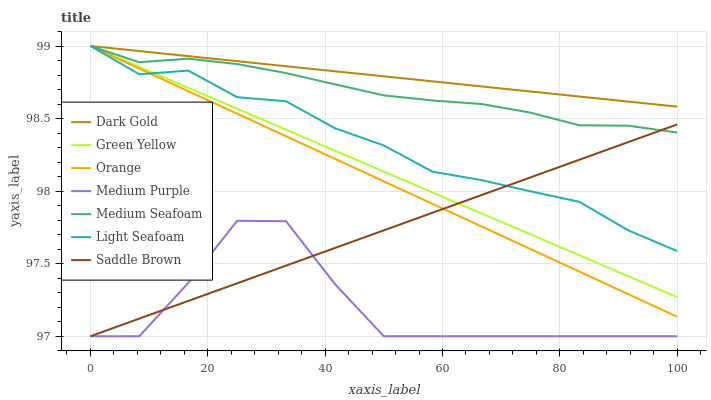Does Medium Purple have the minimum area under the curve?
Answer yes or no. Yes. Does Dark Gold have the maximum area under the curve?
Answer yes or no. Yes. Does Saddle Brown have the minimum area under the curve?
Answer yes or no. No. Does Saddle Brown have the maximum area under the curve?
Answer yes or no. No. Is Dark Gold the smoothest?
Answer yes or no. Yes. Is Medium Purple the roughest?
Answer yes or no. Yes. Is Saddle Brown the smoothest?
Answer yes or no. No. Is Saddle Brown the roughest?
Answer yes or no. No. Does Saddle Brown have the lowest value?
Answer yes or no. Yes. Does Dark Gold have the lowest value?
Answer yes or no. No. Does Medium Seafoam have the highest value?
Answer yes or no. Yes. Does Saddle Brown have the highest value?
Answer yes or no. No. Is Medium Purple less than Dark Gold?
Answer yes or no. Yes. Is Medium Seafoam greater than Medium Purple?
Answer yes or no. Yes. Does Green Yellow intersect Saddle Brown?
Answer yes or no. Yes. Is Green Yellow less than Saddle Brown?
Answer yes or no. No. Is Green Yellow greater than Saddle Brown?
Answer yes or no. No. Does Medium Purple intersect Dark Gold?
Answer yes or no. No. 